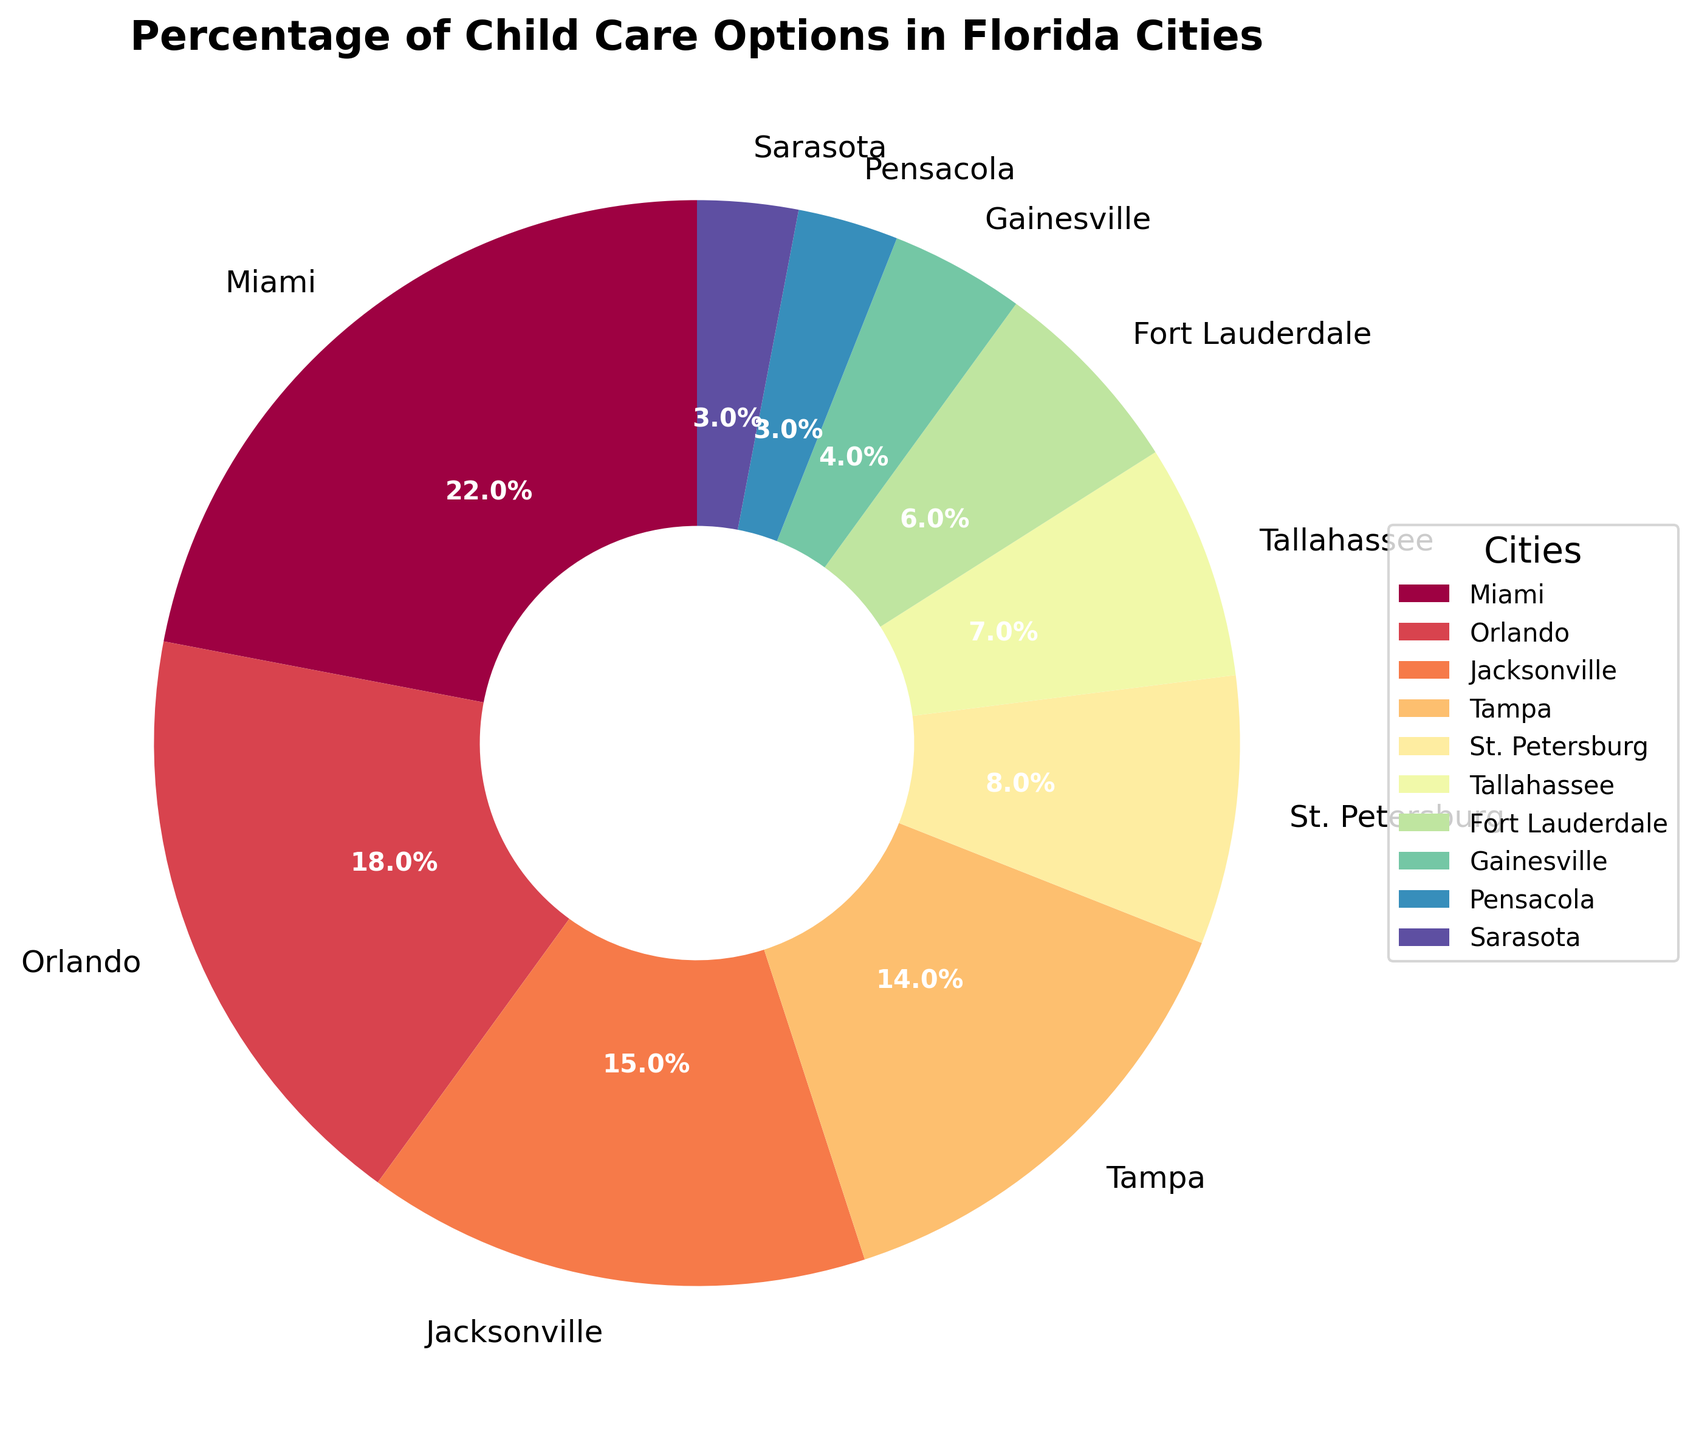What percentage of child care options does Miami have? Miami is labeled on the pie chart with "22%", indicating it has 22% of the child care options.
Answer: 22% Is the percentage of child care options in Orlando greater than that in Tampa? By comparing the slice sizes and labels, Orlando has 18% and Tampa has 14%. Since 18% > 14%, Orlando has a greater percentage than Tampa.
Answer: Yes What is the difference in percentage of child care options between Jacksonville and Fort Lauderdale? Jacksonville's label shows 15%, and Fort Lauderdale's shows 6%. The difference is 15% - 6% = 9%.
Answer: 9% Which city has the smallest percentage of child care options? Pensacola and Sarasota both have the smallest slices with labels showing 3%.
Answer: Pensacola or Sarasota How many cities have a percentage of child care options greater than 10%? By checking each label: Miami (22%), Orlando (18%), Jacksonville (15%), and Tampa (14%) are above 10%. Therefore, there are 4 cities.
Answer: 4 What is the combined percentage of child care options for St. Petersburg, Tallahassee, and Gainesville? The labels show 8% (St. Petersburg) + 7% (Tallahassee) + 4% (Gainesville). Summing these percentages: 8% + 7% + 4% = 19%.
Answer: 19% Which city has the second highest percentage of child care options? Miami has the highest with 22%. The next highest is Orlando with 18%.
Answer: Orlando Are there more cities with a percentage of child care options less than 10% or more than 10%? Cities with less than 10%: St. Petersburg, Tallahassee, Fort Lauderdale, Gainesville, Pensacola, Sarasota (6 cities). Cities with more than 10%: Miami, Orlando, Jacksonville, Tampa (4 cities). There are more cities with less than 10%.
Answer: More cities have less than 10% What's the average percentage of child care options for the cities listed? Summing all percentages: 22% + 18% + 15% + 14% + 8% + 7% + 6% + 4% + 3% + 3% = 100%. There are 10 cities, so the average is 100%/10 = 10%.
Answer: 10% What percentage of child care options do Miami and Orlando together account for? Miami has 22% and Orlando has 18%. Combined, this gives 22% + 18% = 40%.
Answer: 40% 